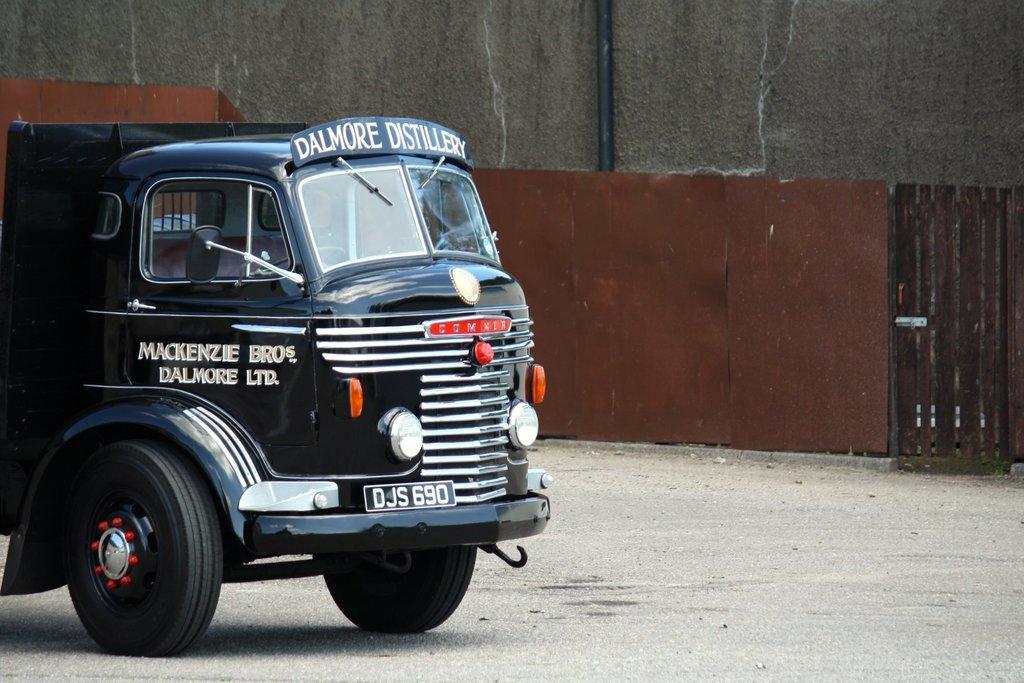In one or two sentences, can you explain what this image depicts? In this image I can see a vehicle on the ground which is black in color. In the background I can see a wall and a gate. 